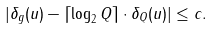Convert formula to latex. <formula><loc_0><loc_0><loc_500><loc_500>| \delta _ { g } ( u ) - \lceil \log _ { 2 } Q \rceil \cdot \delta _ { Q } ( u ) | \leq c .</formula> 